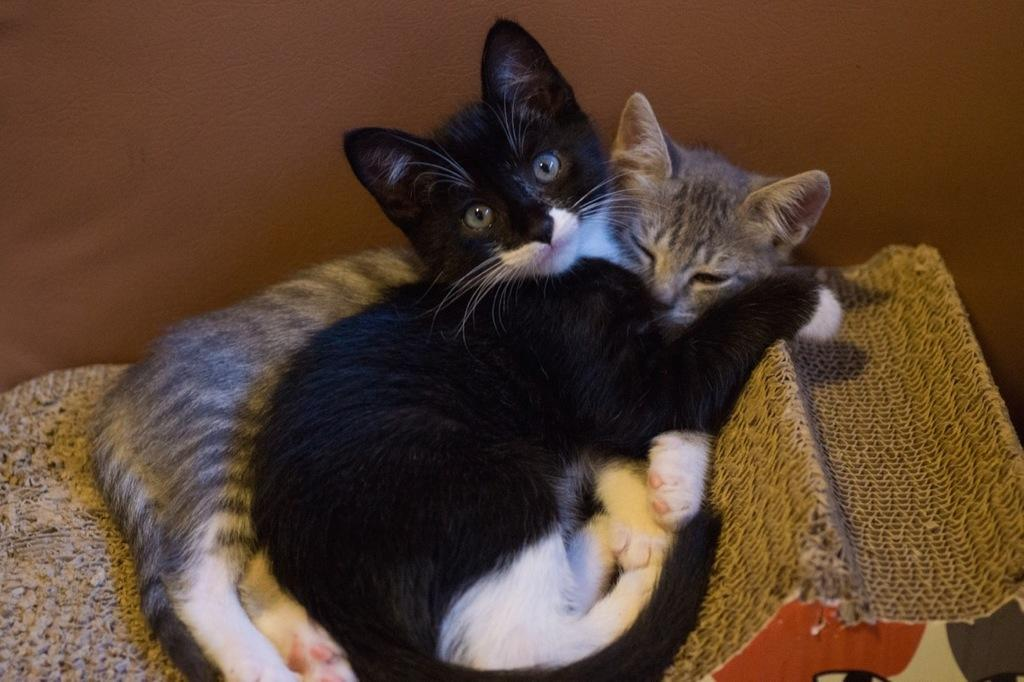How many cats are in the image? There are two cats in the image. What are the cats doing in the image? The cats are sitting on chairs. What can be seen in the background of the image? There is a wall in the background of the image. What type of stick is the cat holding in the image? There is no stick present in the image; the cats are sitting on chairs without any objects in their paws. 